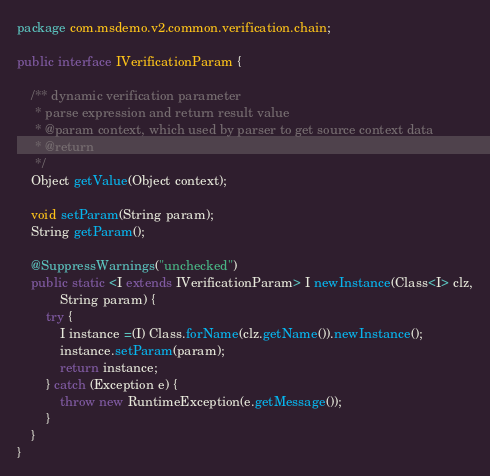Convert code to text. <code><loc_0><loc_0><loc_500><loc_500><_Java_>package com.msdemo.v2.common.verification.chain;

public interface IVerificationParam {
	
	/** dynamic verification parameter
	 * parse expression and return result value
	 * @param context, which used by parser to get source context data 
	 * @return
	 */
	Object getValue(Object context);
	
	void setParam(String param);
	String getParam();
	
	@SuppressWarnings("unchecked")
	public static <I extends IVerificationParam> I newInstance(Class<I> clz,
			String param) {
		try {
			I instance =(I) Class.forName(clz.getName()).newInstance();
			instance.setParam(param);
			return instance;
		} catch (Exception e) {
			throw new RuntimeException(e.getMessage());
		}
	}
}
</code> 